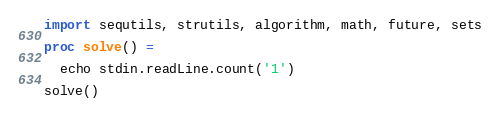<code> <loc_0><loc_0><loc_500><loc_500><_Nim_>import sequtils, strutils, algorithm, math, future, sets

proc solve() =

  echo stdin.readLine.count('1')

solve()</code> 